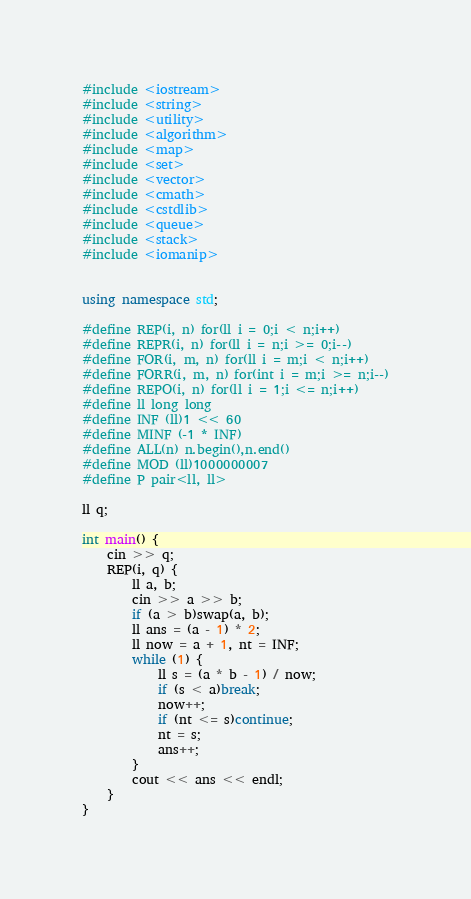Convert code to text. <code><loc_0><loc_0><loc_500><loc_500><_C++_>#include <iostream>
#include <string>
#include <utility>
#include <algorithm>
#include <map>
#include <set>
#include <vector>
#include <cmath>
#include <cstdlib>
#include <queue>
#include <stack>
#include <iomanip>


using namespace std;

#define REP(i, n) for(ll i = 0;i < n;i++)
#define REPR(i, n) for(ll i = n;i >= 0;i--)
#define FOR(i, m, n) for(ll i = m;i < n;i++)
#define FORR(i, m, n) for(int i = m;i >= n;i--)
#define REPO(i, n) for(ll i = 1;i <= n;i++)
#define ll long long
#define INF (ll)1 << 60
#define MINF (-1 * INF)
#define ALL(n) n.begin(),n.end()
#define MOD (ll)1000000007
#define P pair<ll, ll>

ll q;

int main() {
	cin >> q;
	REP(i, q) {
		ll a, b;
		cin >> a >> b;
		if (a > b)swap(a, b);
		ll ans = (a - 1) * 2;
		ll now = a + 1, nt = INF;
		while (1) {
			ll s = (a * b - 1) / now;
			if (s < a)break;
			now++;
			if (nt <= s)continue;
			nt = s;
			ans++;
		}
		cout << ans << endl;
	}
}</code> 